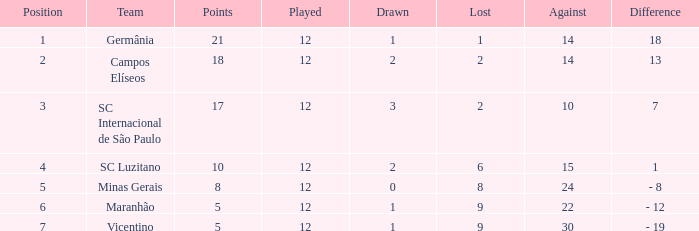In what case is there a difference of over 10 points and under 2 draws? 18.0. 